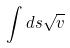Convert formula to latex. <formula><loc_0><loc_0><loc_500><loc_500>\int d s \sqrt { v }</formula> 